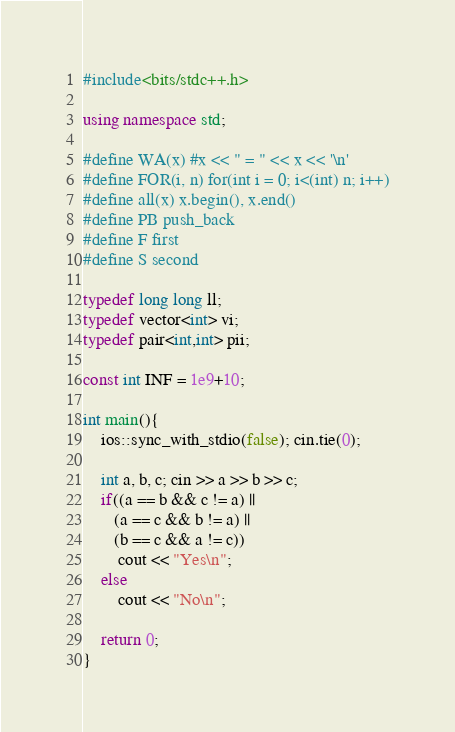<code> <loc_0><loc_0><loc_500><loc_500><_C++_>#include<bits/stdc++.h>

using namespace std;

#define WA(x) #x << " = " << x << '\n'
#define FOR(i, n) for(int i = 0; i<(int) n; i++)
#define all(x) x.begin(), x.end()
#define PB push_back
#define F first
#define S second

typedef long long ll;
typedef vector<int> vi;
typedef pair<int,int> pii;

const int INF = 1e9+10;

int main(){
	ios::sync_with_stdio(false); cin.tie(0);

	int a, b, c; cin >> a >> b >> c;
	if((a == b && c != a) || 
	   (a == c && b != a) ||
	   (b == c && a != c))
		cout << "Yes\n";
	else
		cout << "No\n";

	return 0;
}</code> 